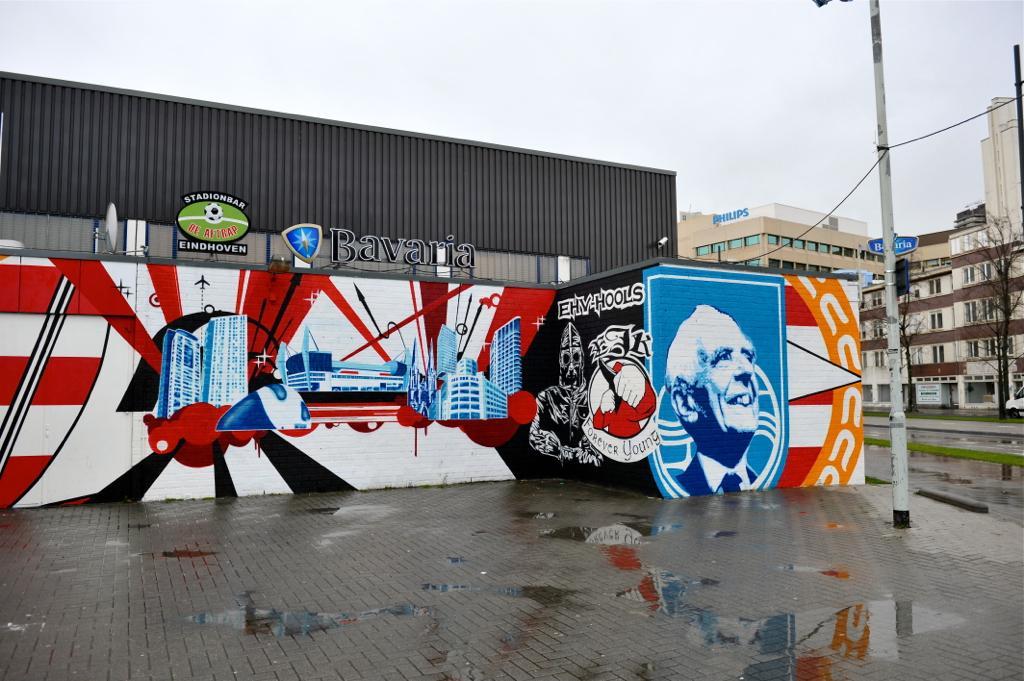How would you summarize this image in a sentence or two? This image consists of buildings in the middle. There is a tree on the right side. There is sky at the top. 